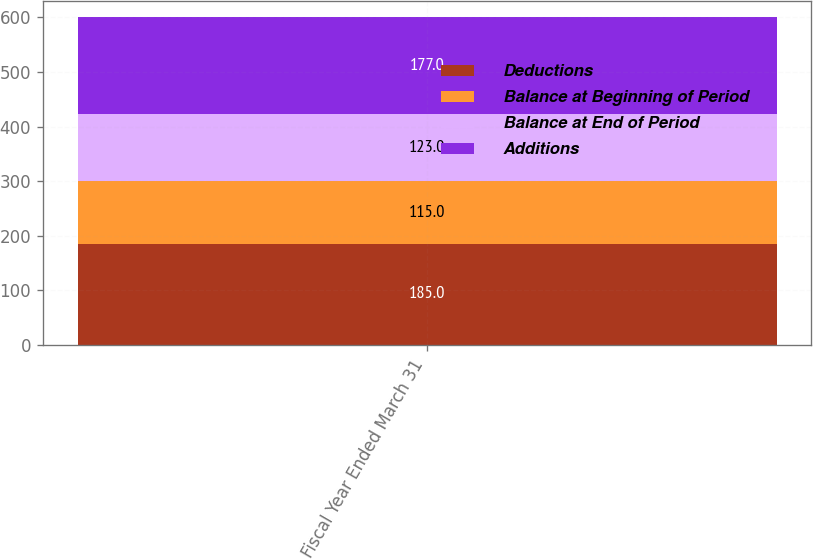Convert chart to OTSL. <chart><loc_0><loc_0><loc_500><loc_500><stacked_bar_chart><ecel><fcel>Fiscal Year Ended March 31<nl><fcel>Deductions<fcel>185<nl><fcel>Balance at Beginning of Period<fcel>115<nl><fcel>Balance at End of Period<fcel>123<nl><fcel>Additions<fcel>177<nl></chart> 